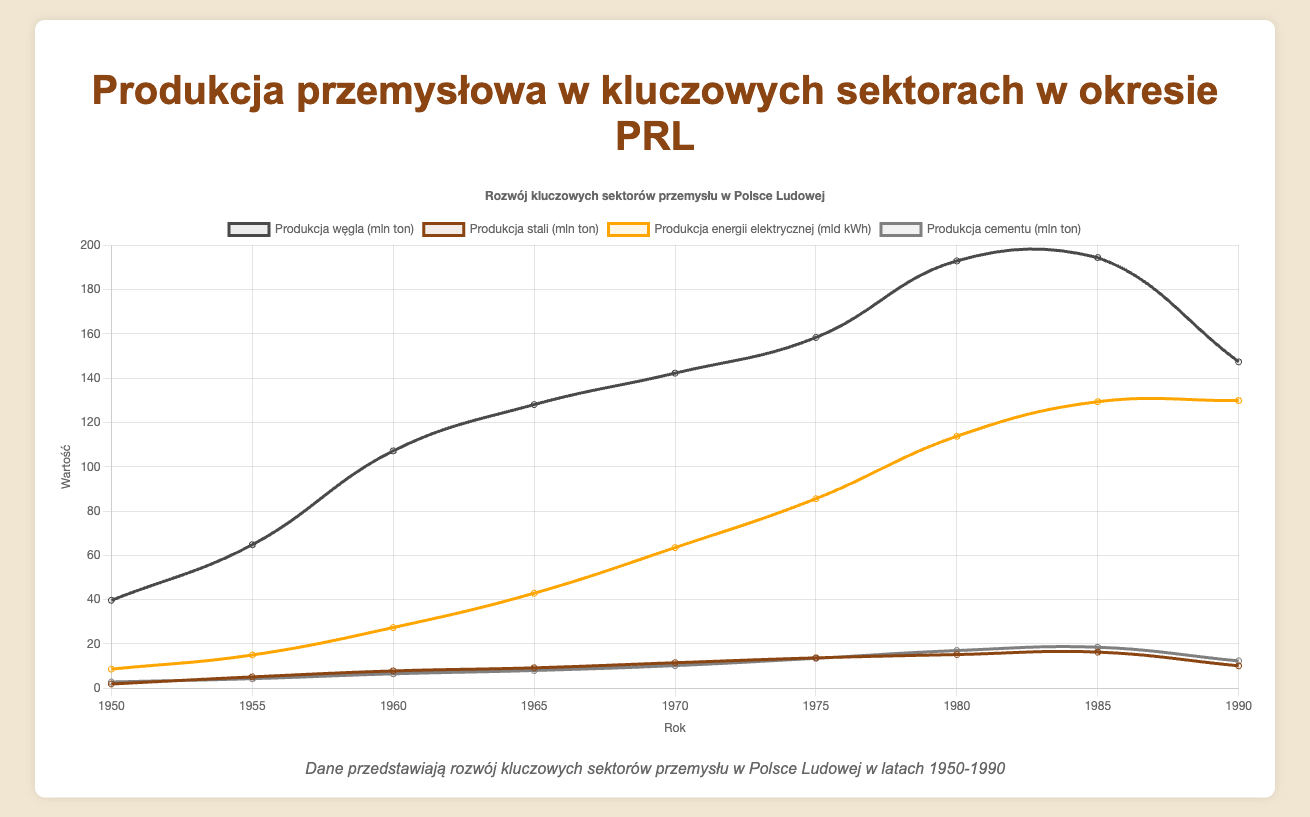Which sector shows the greatest increase in production from 1950 to 1980? First, find the production values for each sector in 1950 and 1980, then calculate the difference for each sector:
Coal: 193.0 - 39.7 = 153.3 million tons
Steel: 15.2 - 1.9 = 13.3 million tons
Electricity: 113.8 - 8.6 = 105.2 billion kWh
Cement: 17.0 - 2.8 = 14.2 million tons
The greatest increase is in coal production.
Answer: Coal production By how many metric tons did steel production change from 1985 to 1990? Find the steel production values for 1985 and 1990, then calculate the difference:
16.3 - 10.1 = 6.2 million tons.
Answer: 6.2 million tons Which year saw the highest production in Mn tons for coal? Identify the year with the highest coal production value:
1950: 39.7
1955: 64.8
1960: 107.2
1965: 128.1
1970: 142.3
1975: 158.4
1980: 193.0
1985: 194.5
1990: 147.4
The highest value is in 1985.
Answer: 1985 What is the trend of cement production from 1950 to 1990? Describe the pattern in cement production:
1950: 2.8
1955: 4.3
1960: 6.5
1965: 8.0
1970: 10.2
1975: 13.5
1980: 17.0
1985: 18.5
1990: 12.3
The trend shows a general increase until 1985, then a decrease by 1990.
Answer: Increasing until 1985, then decreasing Which color represents electricity generation on the plot? Identify the color used for the electricity generation dataset on the plot. The legend shows electricity generation is represented in orange.
Answer: Orange Calculate the average coal production from 1950 to 1990. Add up coal production values and divide by the number of years:
(39.7 + 64.8 + 107.2 + 128.1 + 142.3 + 158.4 + 193.0 + 194.5 + 147.4) / 9 = 130.6 million tons
Answer: 130.6 million tons During which decade did cement production increase the most? Calculate the increase in cement production for each decade:
1950-1960: 6.5 - 2.8 = 3.7 million tons
1960-1970: 10.2 - 6.5 = 3.7 million tons
1970-1980: 17.0 - 10.2 = 6.8 million tons
1980-1990: 12.3 - 17.0 = -4.7 million tons
The greatest increase is between 1970 and 1980.
Answer: 1970s What was the average steel production in the 1970s? Add up steel production values from 1970 and 1975 and divide by the number of years:
(11.5 + 13.7) / 2 = 12.6 million tons
Answer: 12.6 million tons In which decade did coal production see the smallest growth? Calculate the growth in coal production for each decade:
1950-1960: 107.2 - 39.7 = 67.5 million tons
1960-1970: 142.3 - 107.2 = 35.1 million tons
1970-1980: 193.0 - 142.3 = 50.7 million tons
1980-1990: 147.4 - 193.0 = -45.6 million tons
The smallest growth occurred in the 1980s.
Answer: 1980s 